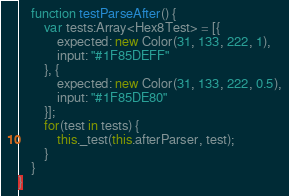Convert code to text. <code><loc_0><loc_0><loc_500><loc_500><_Haxe_>
	function testParseAfter() {
		var tests:Array<Hex8Test> = [{
			expected: new Color(31, 133, 222, 1),
			input: "#1F85DEFF"
		}, {
			expected: new Color(31, 133, 222, 0.5),
			input: "#1F85DE80"
		}];
		for(test in tests) {
			this._test(this.afterParser, test);
		}
	}
}
</code> 